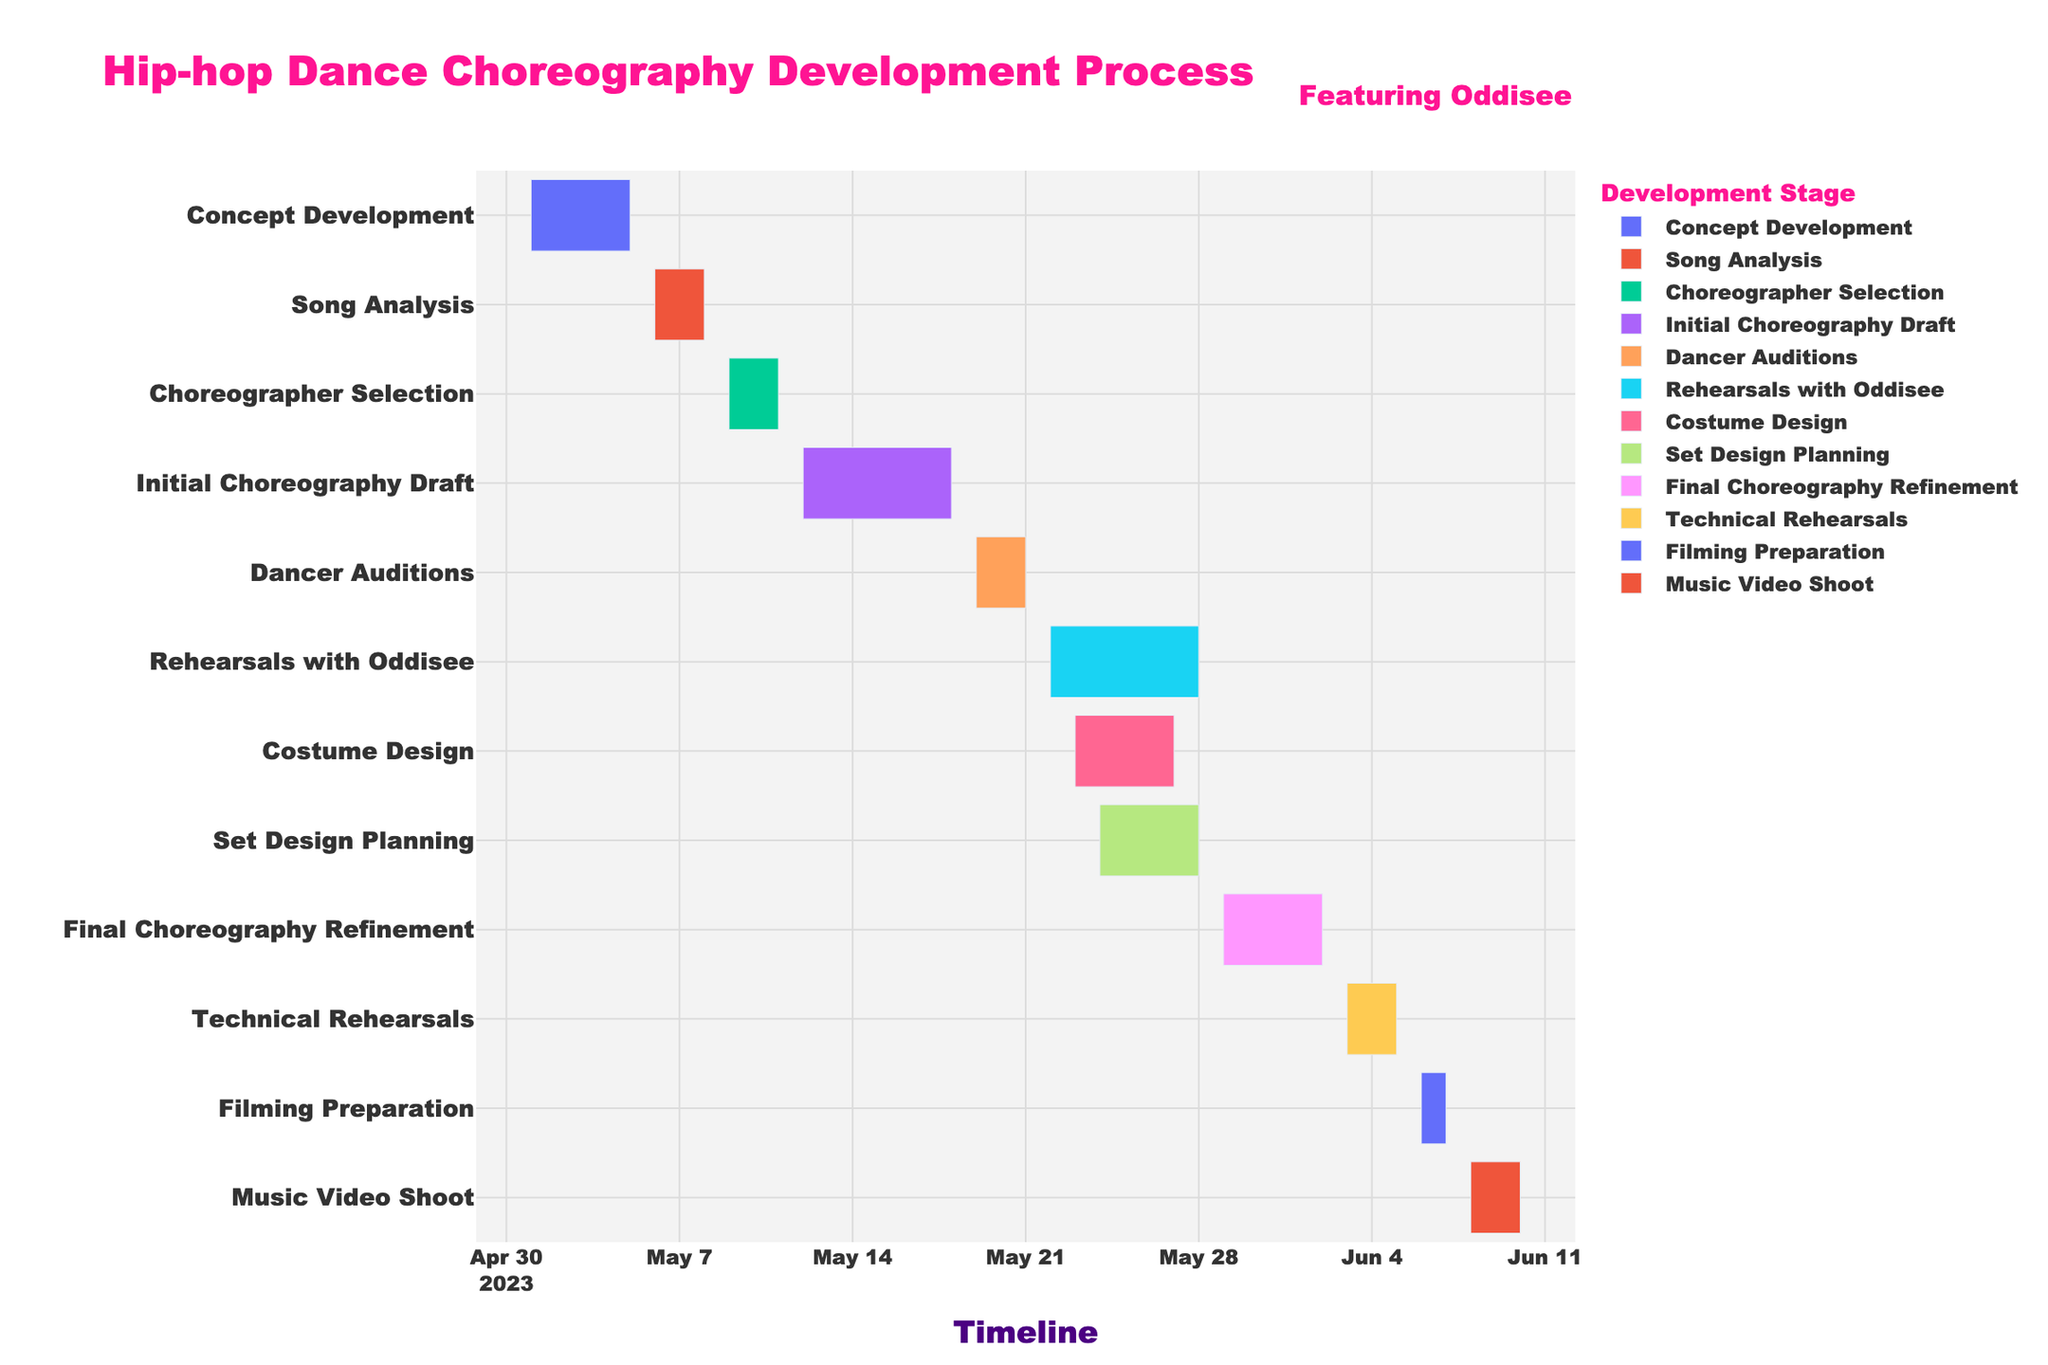What is the title of the figure? The title of the figure is usually placed at the top of the chart. From the visual information in the figure, one can read the title directly.
Answer: Hip-hop Dance Choreography Development Process When does the Initial Choreography Draft start and end? In a Gantt Chart, each task is represented by a bar, showing its duration across the timeline. The bar labeled "Initial Choreography Draft" will show its start and end dates.
Answer: May 12 - May 18 Which tasks are being performed concurrently with the Rehearsals with Oddisee? Look at the timeline for "Rehearsals with Oddisee" and identify the tasks whose bars overlap with this period.
Answer: Costume Design, Set Design Planning How many days does the Final Choreography Refinement take? Calculate the number of days by subtracting the start date from the end date and adding one to include the last day. The bar for "Final Choreography Refinement" clearly indicates the duration.
Answer: 5 days Which task has the shortest duration? Identify the task with the smallest bar or the one showing the fewest days in the timeline.
Answer: Song Analysis What is the total duration of the entire process from Concept Development to Music Video Shoot? Determine the start date of "Concept Development" and the end date of "Music Video Shoot". Subtract the start date from the end date and add one to include the last day.
Answer: 41 days How many tasks are involved in the choreography development process? Count the number of unique bars (tasks) present in the chart. Each bar represents a different task.
Answer: 12 tasks Which task starts immediately after Dancer Auditions? Find when "Dancer Auditions" ends and identify the task that starts on the following day or immediately after.
Answer: Rehearsals with Oddisee What is the overlap period between Costume Design and Set Design Planning? Identify the start and end dates for both tasks and note the period during which both tasks are active together by examining the overlap of their bars.
Answer: May 24-27 